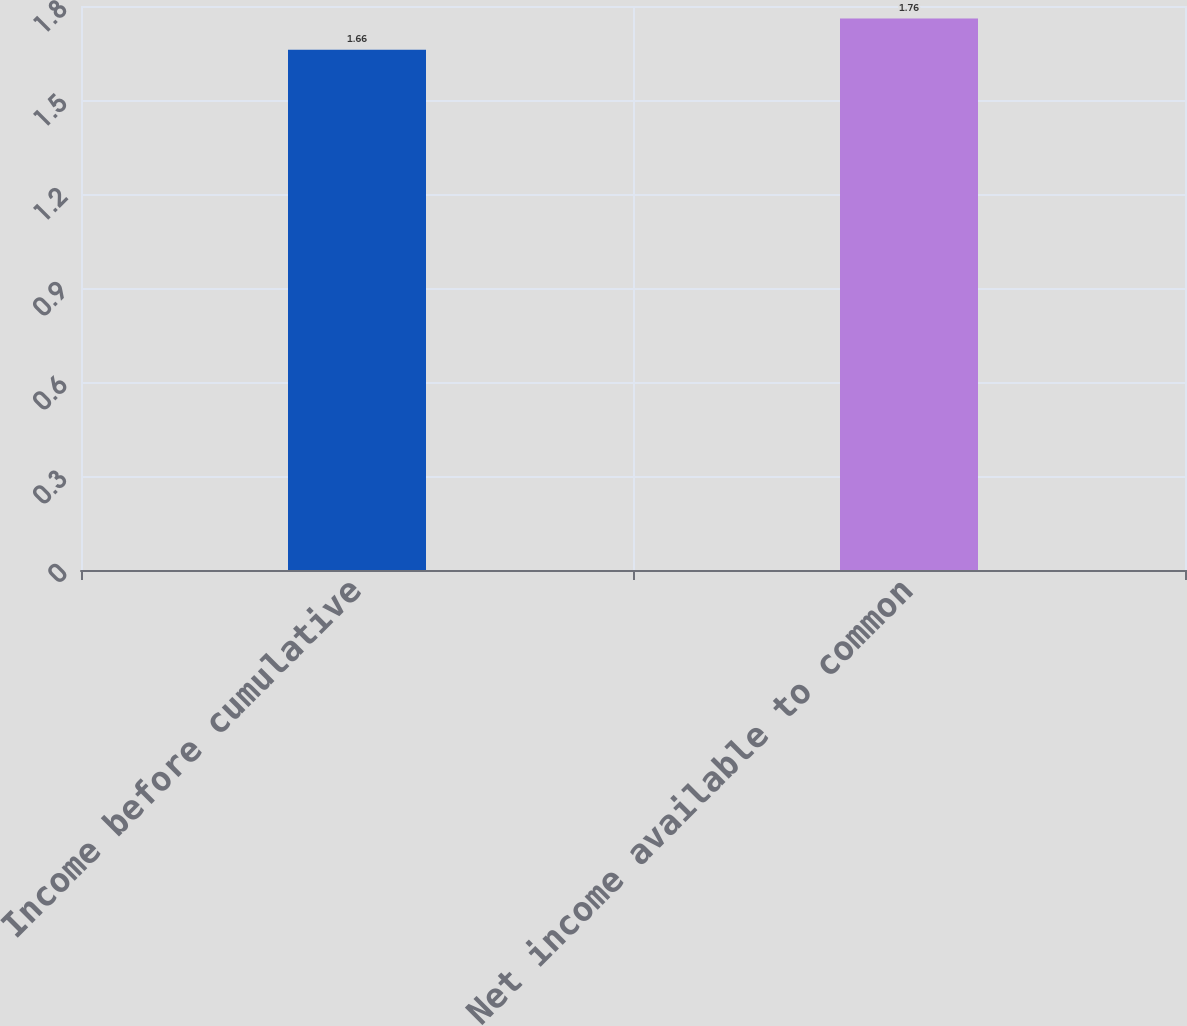Convert chart. <chart><loc_0><loc_0><loc_500><loc_500><bar_chart><fcel>Income before cumulative<fcel>Net income available to common<nl><fcel>1.66<fcel>1.76<nl></chart> 